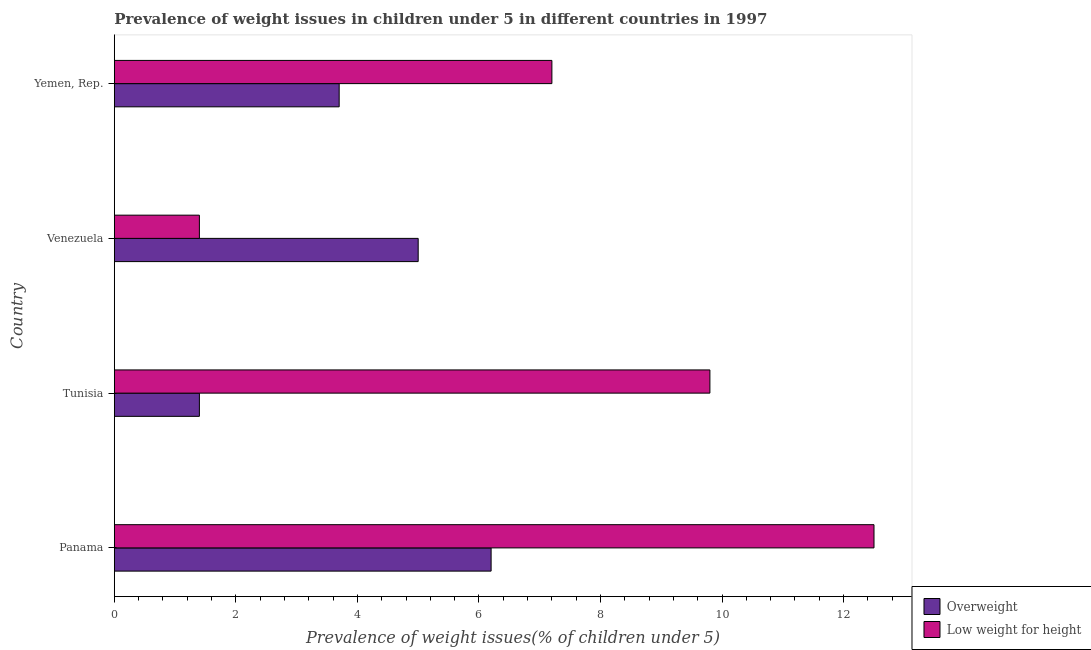How many groups of bars are there?
Your answer should be compact. 4. How many bars are there on the 2nd tick from the bottom?
Your answer should be very brief. 2. What is the label of the 4th group of bars from the top?
Ensure brevity in your answer.  Panama. What is the percentage of underweight children in Tunisia?
Make the answer very short. 9.8. Across all countries, what is the maximum percentage of overweight children?
Ensure brevity in your answer.  6.2. Across all countries, what is the minimum percentage of overweight children?
Provide a short and direct response. 1.4. In which country was the percentage of overweight children maximum?
Your response must be concise. Panama. In which country was the percentage of underweight children minimum?
Offer a very short reply. Venezuela. What is the total percentage of underweight children in the graph?
Give a very brief answer. 30.9. What is the difference between the percentage of overweight children in Yemen, Rep. and the percentage of underweight children in Tunisia?
Keep it short and to the point. -6.1. What is the average percentage of underweight children per country?
Give a very brief answer. 7.72. In how many countries, is the percentage of overweight children greater than 12.4 %?
Make the answer very short. 0. What is the ratio of the percentage of underweight children in Venezuela to that in Yemen, Rep.?
Give a very brief answer. 0.19. Is the difference between the percentage of underweight children in Panama and Venezuela greater than the difference between the percentage of overweight children in Panama and Venezuela?
Your response must be concise. Yes. What is the difference between the highest and the second highest percentage of underweight children?
Your answer should be compact. 2.7. What is the difference between the highest and the lowest percentage of underweight children?
Ensure brevity in your answer.  11.1. What does the 1st bar from the top in Venezuela represents?
Make the answer very short. Low weight for height. What does the 2nd bar from the bottom in Panama represents?
Ensure brevity in your answer.  Low weight for height. How many bars are there?
Keep it short and to the point. 8. Are all the bars in the graph horizontal?
Give a very brief answer. Yes. What is the difference between two consecutive major ticks on the X-axis?
Keep it short and to the point. 2. Are the values on the major ticks of X-axis written in scientific E-notation?
Your response must be concise. No. Does the graph contain any zero values?
Keep it short and to the point. No. Does the graph contain grids?
Offer a very short reply. No. Where does the legend appear in the graph?
Give a very brief answer. Bottom right. How many legend labels are there?
Your answer should be compact. 2. How are the legend labels stacked?
Your answer should be compact. Vertical. What is the title of the graph?
Offer a very short reply. Prevalence of weight issues in children under 5 in different countries in 1997. Does "Forest" appear as one of the legend labels in the graph?
Make the answer very short. No. What is the label or title of the X-axis?
Your response must be concise. Prevalence of weight issues(% of children under 5). What is the label or title of the Y-axis?
Provide a succinct answer. Country. What is the Prevalence of weight issues(% of children under 5) in Overweight in Panama?
Offer a very short reply. 6.2. What is the Prevalence of weight issues(% of children under 5) of Overweight in Tunisia?
Your answer should be very brief. 1.4. What is the Prevalence of weight issues(% of children under 5) in Low weight for height in Tunisia?
Give a very brief answer. 9.8. What is the Prevalence of weight issues(% of children under 5) of Low weight for height in Venezuela?
Your answer should be compact. 1.4. What is the Prevalence of weight issues(% of children under 5) in Overweight in Yemen, Rep.?
Offer a very short reply. 3.7. What is the Prevalence of weight issues(% of children under 5) of Low weight for height in Yemen, Rep.?
Your answer should be compact. 7.2. Across all countries, what is the maximum Prevalence of weight issues(% of children under 5) of Overweight?
Your answer should be very brief. 6.2. Across all countries, what is the minimum Prevalence of weight issues(% of children under 5) in Overweight?
Your answer should be compact. 1.4. Across all countries, what is the minimum Prevalence of weight issues(% of children under 5) in Low weight for height?
Ensure brevity in your answer.  1.4. What is the total Prevalence of weight issues(% of children under 5) in Overweight in the graph?
Offer a very short reply. 16.3. What is the total Prevalence of weight issues(% of children under 5) of Low weight for height in the graph?
Provide a succinct answer. 30.9. What is the difference between the Prevalence of weight issues(% of children under 5) of Overweight in Panama and that in Tunisia?
Your response must be concise. 4.8. What is the difference between the Prevalence of weight issues(% of children under 5) in Overweight in Panama and that in Venezuela?
Your answer should be compact. 1.2. What is the difference between the Prevalence of weight issues(% of children under 5) of Low weight for height in Panama and that in Venezuela?
Provide a short and direct response. 11.1. What is the difference between the Prevalence of weight issues(% of children under 5) of Overweight in Panama and that in Yemen, Rep.?
Provide a short and direct response. 2.5. What is the difference between the Prevalence of weight issues(% of children under 5) in Overweight in Tunisia and that in Venezuela?
Your response must be concise. -3.6. What is the difference between the Prevalence of weight issues(% of children under 5) in Low weight for height in Tunisia and that in Venezuela?
Your answer should be compact. 8.4. What is the difference between the Prevalence of weight issues(% of children under 5) in Low weight for height in Tunisia and that in Yemen, Rep.?
Offer a very short reply. 2.6. What is the difference between the Prevalence of weight issues(% of children under 5) of Low weight for height in Venezuela and that in Yemen, Rep.?
Your answer should be compact. -5.8. What is the difference between the Prevalence of weight issues(% of children under 5) of Overweight in Panama and the Prevalence of weight issues(% of children under 5) of Low weight for height in Tunisia?
Your answer should be very brief. -3.6. What is the difference between the Prevalence of weight issues(% of children under 5) of Overweight in Panama and the Prevalence of weight issues(% of children under 5) of Low weight for height in Venezuela?
Make the answer very short. 4.8. What is the difference between the Prevalence of weight issues(% of children under 5) of Overweight in Tunisia and the Prevalence of weight issues(% of children under 5) of Low weight for height in Yemen, Rep.?
Keep it short and to the point. -5.8. What is the difference between the Prevalence of weight issues(% of children under 5) of Overweight in Venezuela and the Prevalence of weight issues(% of children under 5) of Low weight for height in Yemen, Rep.?
Your answer should be very brief. -2.2. What is the average Prevalence of weight issues(% of children under 5) in Overweight per country?
Your answer should be compact. 4.08. What is the average Prevalence of weight issues(% of children under 5) of Low weight for height per country?
Ensure brevity in your answer.  7.72. What is the difference between the Prevalence of weight issues(% of children under 5) in Overweight and Prevalence of weight issues(% of children under 5) in Low weight for height in Yemen, Rep.?
Offer a terse response. -3.5. What is the ratio of the Prevalence of weight issues(% of children under 5) in Overweight in Panama to that in Tunisia?
Your answer should be very brief. 4.43. What is the ratio of the Prevalence of weight issues(% of children under 5) of Low weight for height in Panama to that in Tunisia?
Your response must be concise. 1.28. What is the ratio of the Prevalence of weight issues(% of children under 5) in Overweight in Panama to that in Venezuela?
Your answer should be compact. 1.24. What is the ratio of the Prevalence of weight issues(% of children under 5) of Low weight for height in Panama to that in Venezuela?
Provide a succinct answer. 8.93. What is the ratio of the Prevalence of weight issues(% of children under 5) of Overweight in Panama to that in Yemen, Rep.?
Your answer should be compact. 1.68. What is the ratio of the Prevalence of weight issues(% of children under 5) in Low weight for height in Panama to that in Yemen, Rep.?
Provide a succinct answer. 1.74. What is the ratio of the Prevalence of weight issues(% of children under 5) in Overweight in Tunisia to that in Venezuela?
Make the answer very short. 0.28. What is the ratio of the Prevalence of weight issues(% of children under 5) in Low weight for height in Tunisia to that in Venezuela?
Offer a terse response. 7. What is the ratio of the Prevalence of weight issues(% of children under 5) of Overweight in Tunisia to that in Yemen, Rep.?
Your answer should be very brief. 0.38. What is the ratio of the Prevalence of weight issues(% of children under 5) of Low weight for height in Tunisia to that in Yemen, Rep.?
Give a very brief answer. 1.36. What is the ratio of the Prevalence of weight issues(% of children under 5) in Overweight in Venezuela to that in Yemen, Rep.?
Give a very brief answer. 1.35. What is the ratio of the Prevalence of weight issues(% of children under 5) in Low weight for height in Venezuela to that in Yemen, Rep.?
Offer a very short reply. 0.19. What is the difference between the highest and the second highest Prevalence of weight issues(% of children under 5) of Low weight for height?
Make the answer very short. 2.7. What is the difference between the highest and the lowest Prevalence of weight issues(% of children under 5) in Overweight?
Ensure brevity in your answer.  4.8. 